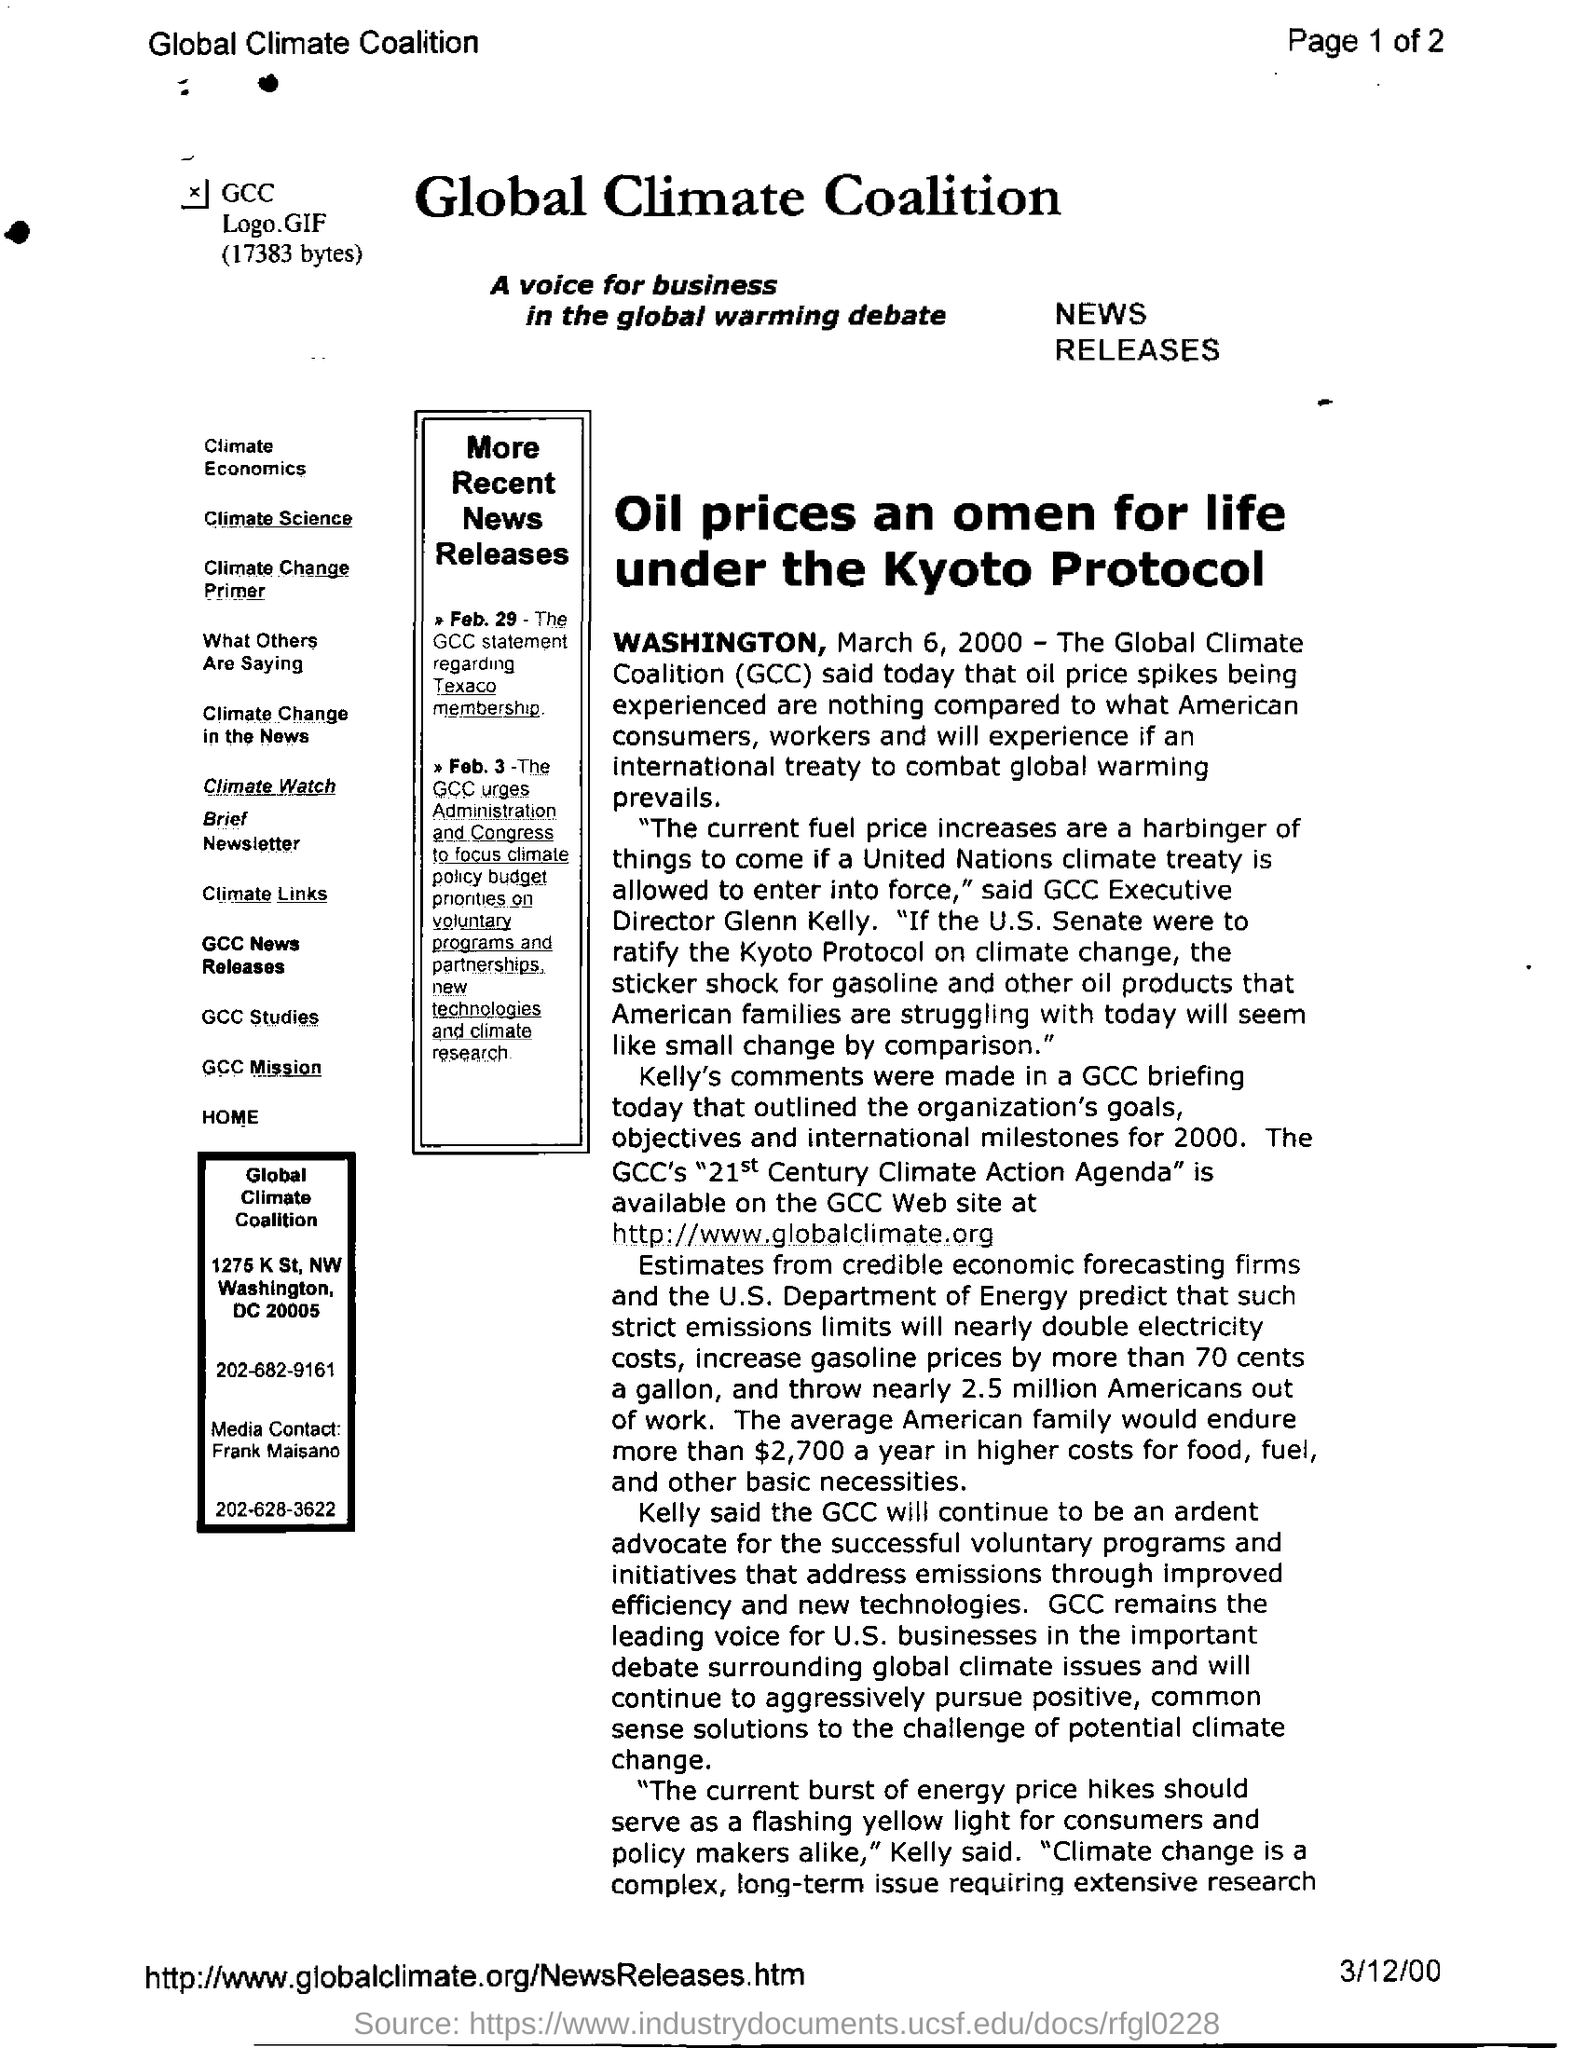What is the full form of GCC?
Your answer should be very brief. Global Climate Coalition. 